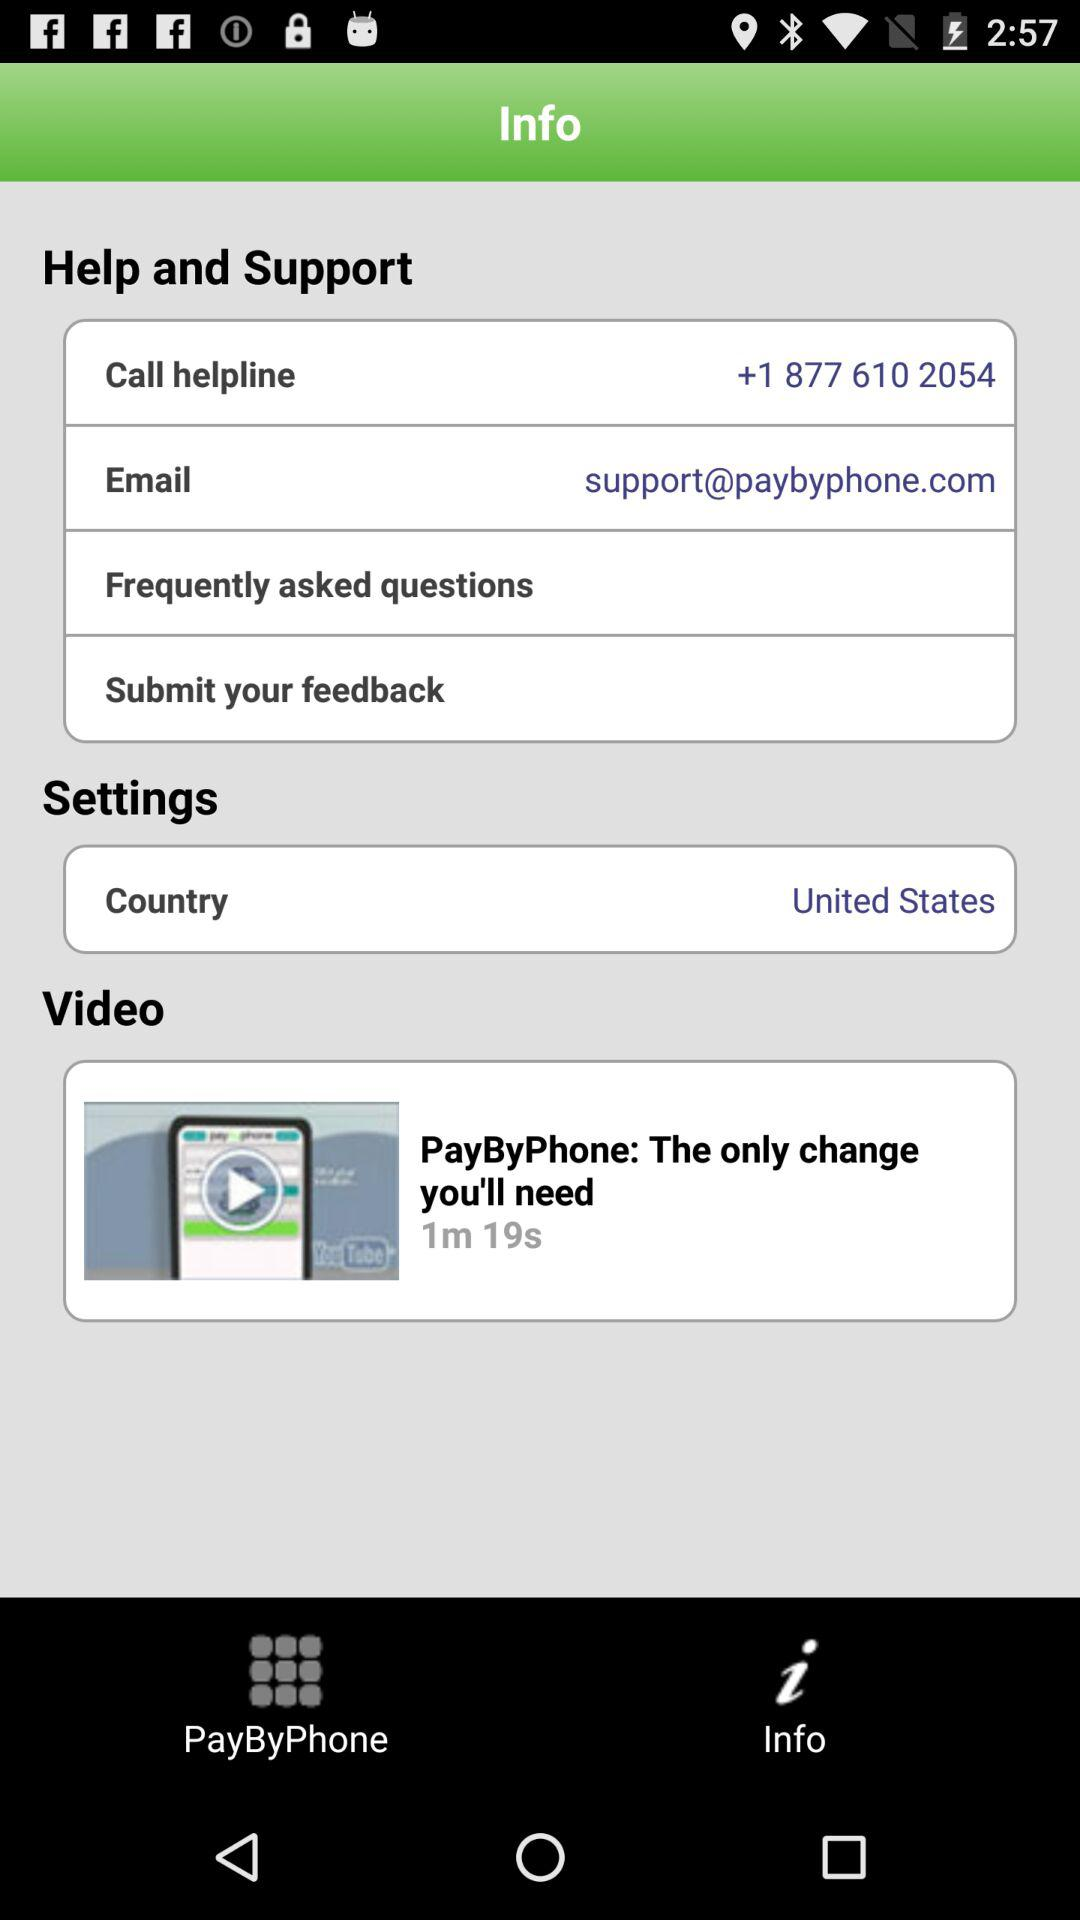What is the name of the application? The name of the application is "PayByPhone". 